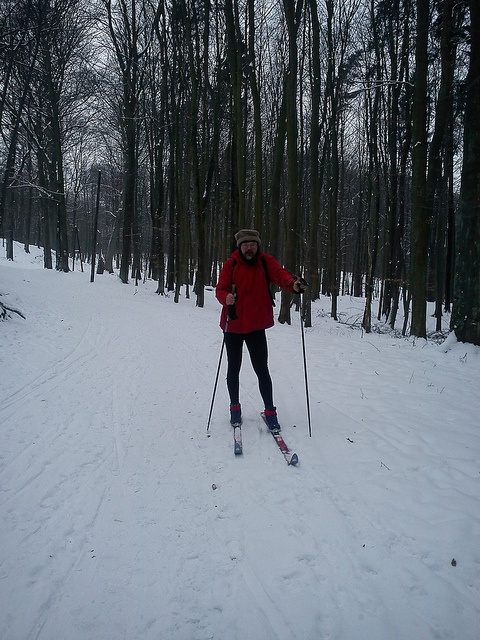Describe the objects in this image and their specific colors. I can see people in darkblue, black, maroon, darkgray, and gray tones and skis in darkblue, darkgray, gray, purple, and blue tones in this image. 